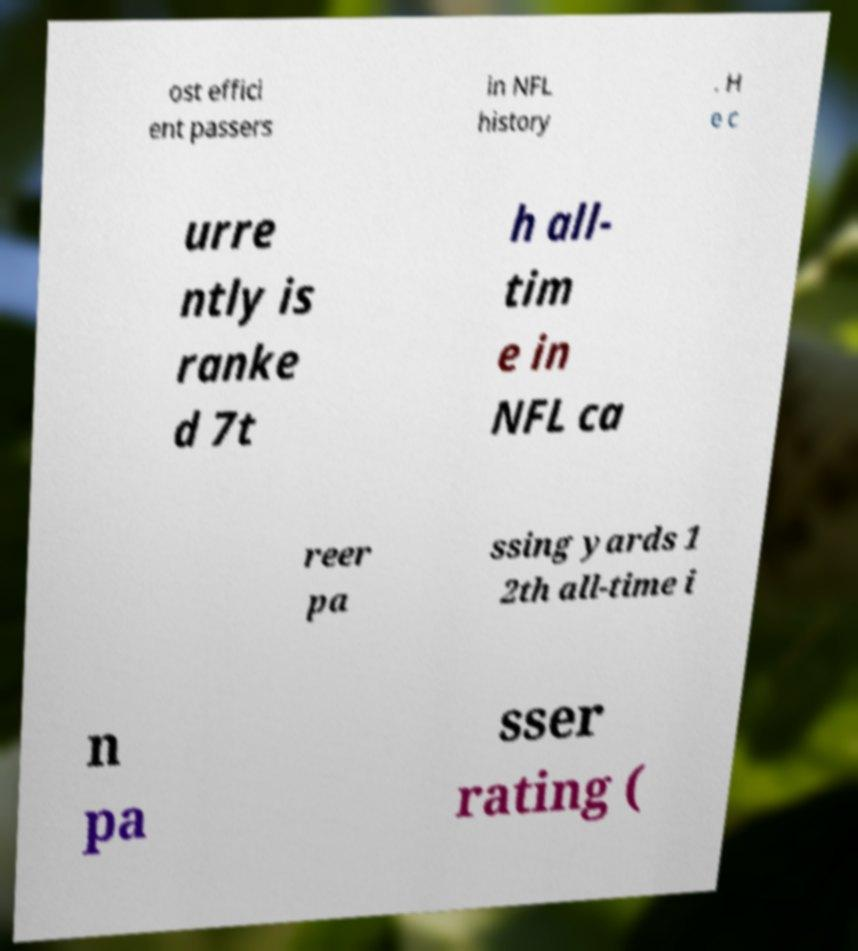I need the written content from this picture converted into text. Can you do that? ost effici ent passers in NFL history . H e c urre ntly is ranke d 7t h all- tim e in NFL ca reer pa ssing yards 1 2th all-time i n pa sser rating ( 